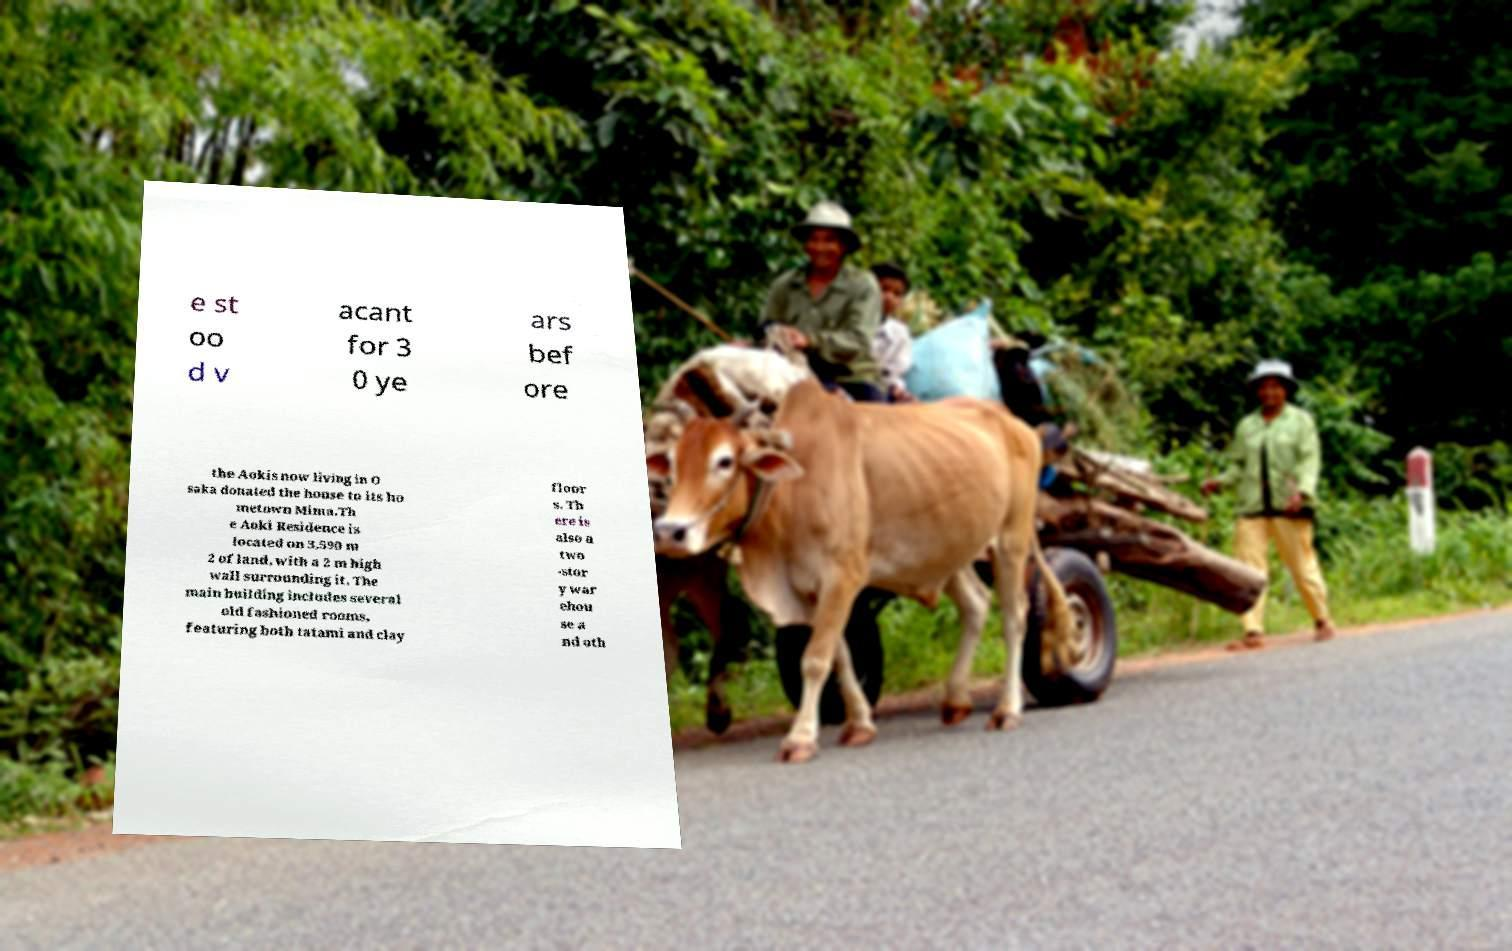Can you read and provide the text displayed in the image?This photo seems to have some interesting text. Can you extract and type it out for me? e st oo d v acant for 3 0 ye ars bef ore the Aokis now living in O saka donated the house to its ho metown Mima.Th e Aoki Residence is located on 3,590 m 2 of land, with a 2 m high wall surrounding it. The main building includes several old fashioned rooms, featuring both tatami and clay floor s. Th ere is also a two -stor y war ehou se a nd oth 